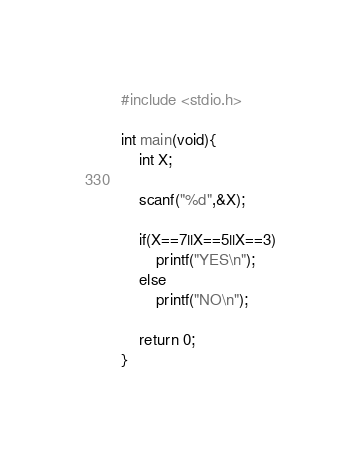Convert code to text. <code><loc_0><loc_0><loc_500><loc_500><_C_>#include <stdio.h>

int main(void){
    int X;

    scanf("%d",&X);
    
    if(X==7||X==5||X==3)
        printf("YES\n");
    else
        printf("NO\n");
        
    return 0;
}
</code> 